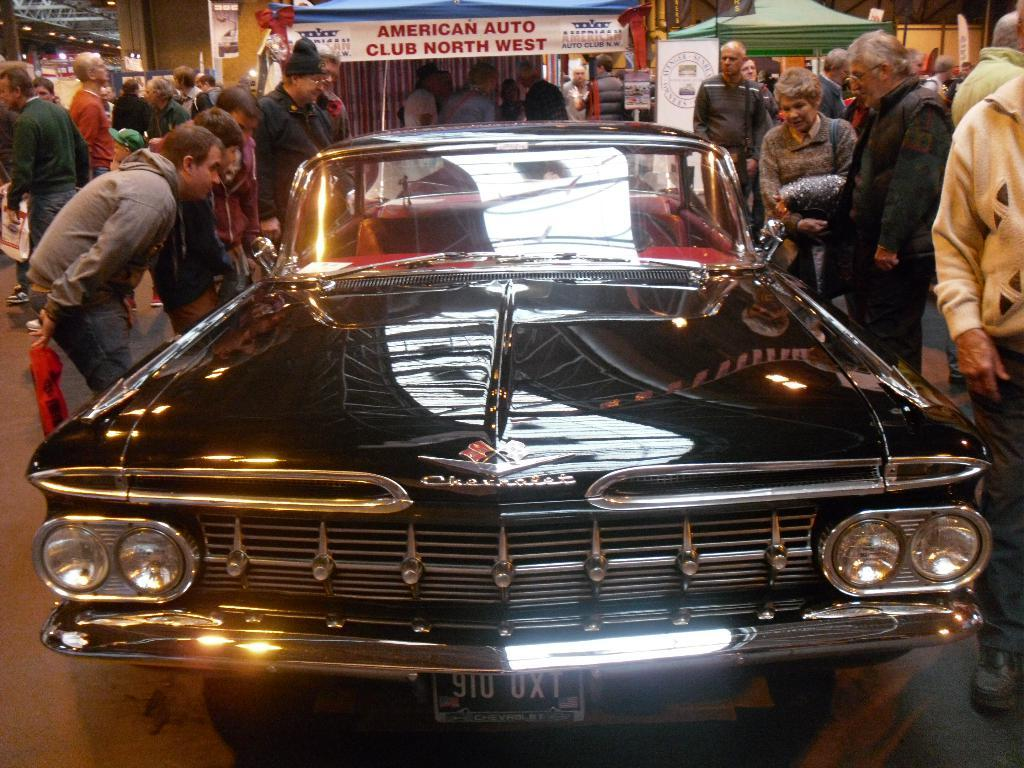What color is the car in the image? The car in the image is black. What are the people in the image doing? The people in the image are standing on the ground. What can be seen in the background of the image? There are banners in the background of the image, and they have something written on them. What else is visible in the background of the image? There are other objects visible in the background of the image. What type of quince is being served at the event depicted in the image? There is no quince or event depicted in the image; it only shows a black car, people standing on the ground, and banners in the background. 